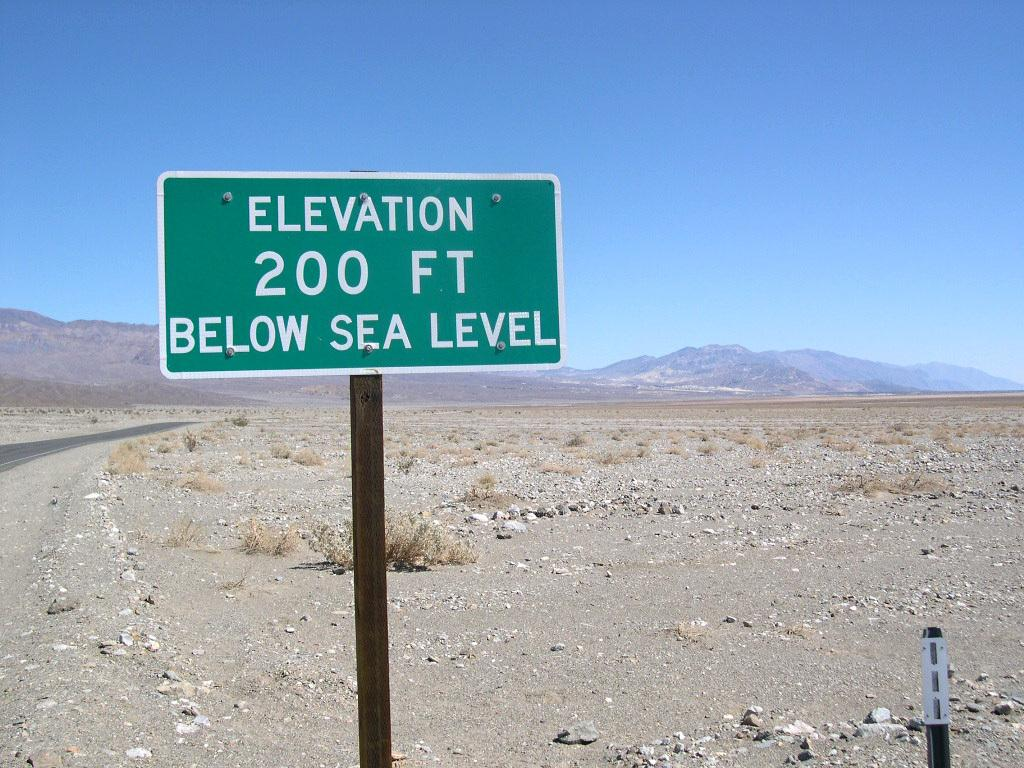Provide a one-sentence caption for the provided image. A green sign states that the elevation is 200 feet below sea level. 